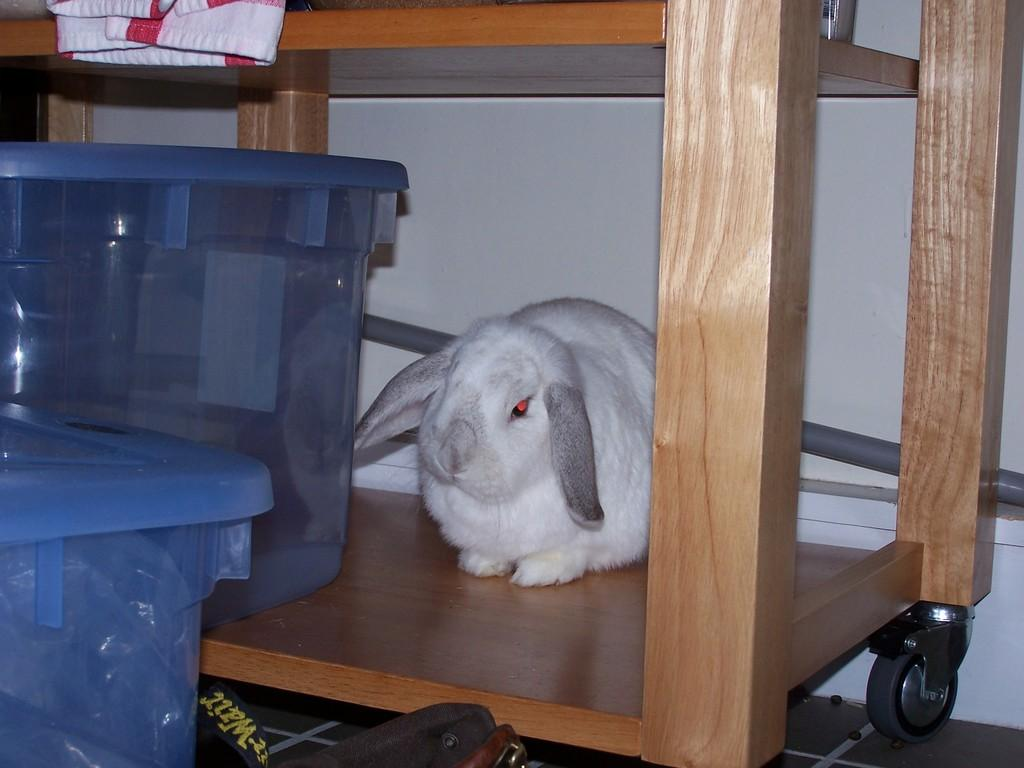What type of animal can be seen in the image? There is a rabbit in the image. What is the table in the image like? There is a table with wheels in the image. What are the plastic containers used for? The plastic containers are used for storing or organizing items. Can you describe the background of the image? There is a wall in the background of the image. What other objects can be seen in the image? There are other objects in the image, but their specific details are not mentioned in the provided facts. What is the name of the rabbit's sister in the image? There is no mention of a sister or any other rabbits in the image, so this information cannot be determined. 